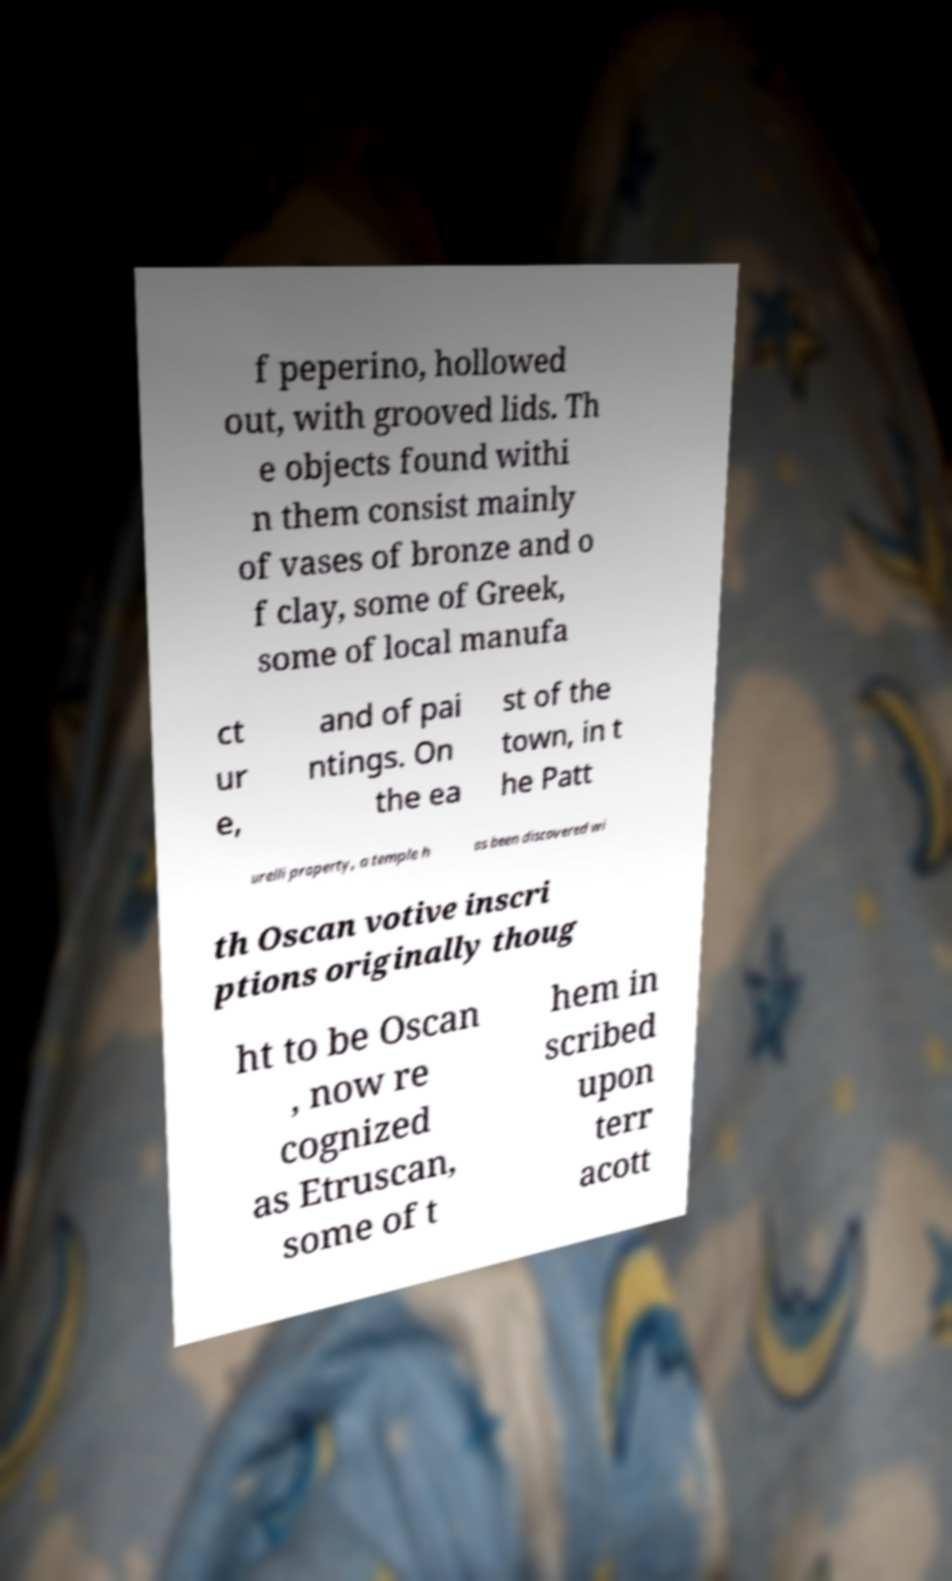Could you assist in decoding the text presented in this image and type it out clearly? f peperino, hollowed out, with grooved lids. Th e objects found withi n them consist mainly of vases of bronze and o f clay, some of Greek, some of local manufa ct ur e, and of pai ntings. On the ea st of the town, in t he Patt urelli property, a temple h as been discovered wi th Oscan votive inscri ptions originally thoug ht to be Oscan , now re cognized as Etruscan, some of t hem in scribed upon terr acott 